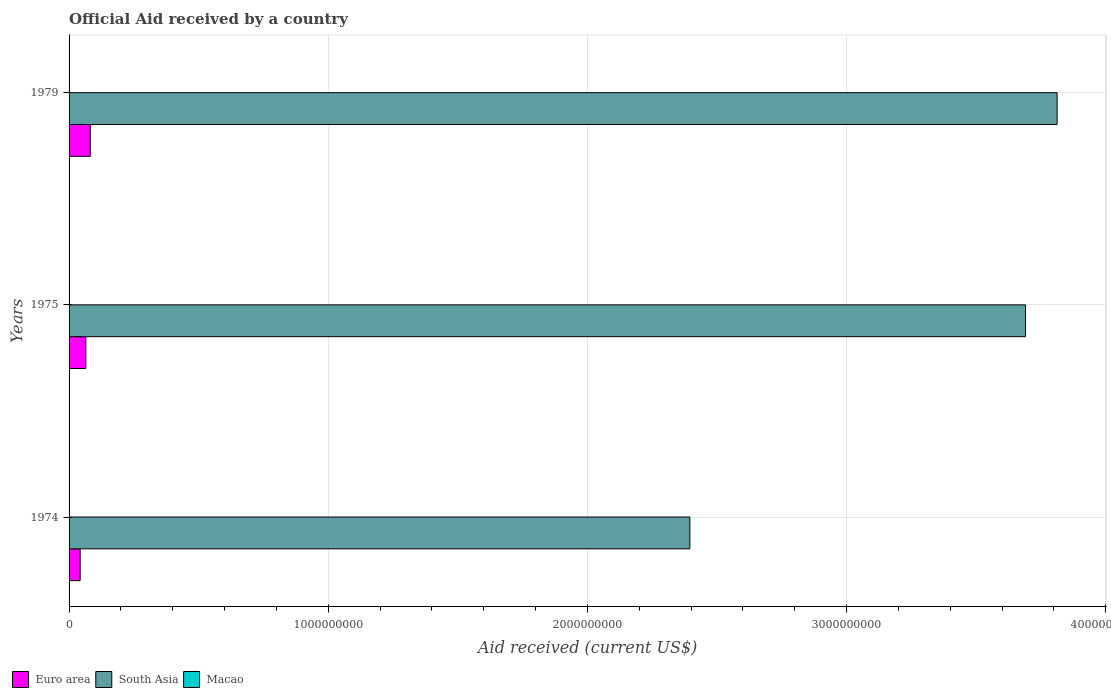How many bars are there on the 1st tick from the top?
Offer a very short reply. 3. What is the label of the 2nd group of bars from the top?
Keep it short and to the point. 1975. What is the net official aid received in Macao in 1975?
Give a very brief answer. 2.00e+04. Across all years, what is the maximum net official aid received in South Asia?
Your answer should be compact. 3.81e+09. Across all years, what is the minimum net official aid received in Euro area?
Make the answer very short. 4.28e+07. In which year was the net official aid received in Macao maximum?
Give a very brief answer. 1974. In which year was the net official aid received in Euro area minimum?
Make the answer very short. 1974. What is the total net official aid received in Euro area in the graph?
Make the answer very short. 1.89e+08. What is the difference between the net official aid received in Euro area in 1975 and that in 1979?
Offer a terse response. -1.69e+07. What is the difference between the net official aid received in South Asia in 1975 and the net official aid received in Euro area in 1974?
Provide a short and direct response. 3.65e+09. What is the average net official aid received in South Asia per year?
Your answer should be very brief. 3.30e+09. In the year 1974, what is the difference between the net official aid received in Macao and net official aid received in South Asia?
Provide a succinct answer. -2.40e+09. What is the ratio of the net official aid received in Euro area in 1975 to that in 1979?
Give a very brief answer. 0.79. Is the net official aid received in South Asia in 1974 less than that in 1979?
Your answer should be very brief. Yes. What is the difference between the highest and the lowest net official aid received in South Asia?
Your answer should be very brief. 1.42e+09. What does the 2nd bar from the top in 1974 represents?
Provide a succinct answer. South Asia. What does the 3rd bar from the bottom in 1979 represents?
Make the answer very short. Macao. Are all the bars in the graph horizontal?
Provide a succinct answer. Yes. What is the difference between two consecutive major ticks on the X-axis?
Keep it short and to the point. 1.00e+09. Does the graph contain any zero values?
Provide a succinct answer. No. Does the graph contain grids?
Give a very brief answer. Yes. Where does the legend appear in the graph?
Make the answer very short. Bottom left. How are the legend labels stacked?
Ensure brevity in your answer.  Horizontal. What is the title of the graph?
Keep it short and to the point. Official Aid received by a country. What is the label or title of the X-axis?
Provide a short and direct response. Aid received (current US$). What is the Aid received (current US$) of Euro area in 1974?
Your response must be concise. 4.28e+07. What is the Aid received (current US$) of South Asia in 1974?
Provide a short and direct response. 2.40e+09. What is the Aid received (current US$) of Macao in 1974?
Offer a very short reply. 3.00e+04. What is the Aid received (current US$) in Euro area in 1975?
Provide a succinct answer. 6.48e+07. What is the Aid received (current US$) of South Asia in 1975?
Your answer should be compact. 3.69e+09. What is the Aid received (current US$) of Euro area in 1979?
Offer a very short reply. 8.17e+07. What is the Aid received (current US$) in South Asia in 1979?
Your response must be concise. 3.81e+09. Across all years, what is the maximum Aid received (current US$) of Euro area?
Keep it short and to the point. 8.17e+07. Across all years, what is the maximum Aid received (current US$) of South Asia?
Your answer should be compact. 3.81e+09. Across all years, what is the minimum Aid received (current US$) in Euro area?
Give a very brief answer. 4.28e+07. Across all years, what is the minimum Aid received (current US$) in South Asia?
Keep it short and to the point. 2.40e+09. Across all years, what is the minimum Aid received (current US$) of Macao?
Make the answer very short. 2.00e+04. What is the total Aid received (current US$) in Euro area in the graph?
Your answer should be compact. 1.89e+08. What is the total Aid received (current US$) in South Asia in the graph?
Offer a very short reply. 9.90e+09. What is the difference between the Aid received (current US$) in Euro area in 1974 and that in 1975?
Keep it short and to the point. -2.20e+07. What is the difference between the Aid received (current US$) of South Asia in 1974 and that in 1975?
Offer a very short reply. -1.29e+09. What is the difference between the Aid received (current US$) of Macao in 1974 and that in 1975?
Provide a succinct answer. 10000. What is the difference between the Aid received (current US$) of Euro area in 1974 and that in 1979?
Your answer should be compact. -3.89e+07. What is the difference between the Aid received (current US$) of South Asia in 1974 and that in 1979?
Your response must be concise. -1.42e+09. What is the difference between the Aid received (current US$) in Euro area in 1975 and that in 1979?
Offer a very short reply. -1.69e+07. What is the difference between the Aid received (current US$) of South Asia in 1975 and that in 1979?
Your answer should be very brief. -1.22e+08. What is the difference between the Aid received (current US$) in Macao in 1975 and that in 1979?
Your answer should be compact. 0. What is the difference between the Aid received (current US$) of Euro area in 1974 and the Aid received (current US$) of South Asia in 1975?
Ensure brevity in your answer.  -3.65e+09. What is the difference between the Aid received (current US$) in Euro area in 1974 and the Aid received (current US$) in Macao in 1975?
Give a very brief answer. 4.28e+07. What is the difference between the Aid received (current US$) in South Asia in 1974 and the Aid received (current US$) in Macao in 1975?
Make the answer very short. 2.40e+09. What is the difference between the Aid received (current US$) of Euro area in 1974 and the Aid received (current US$) of South Asia in 1979?
Keep it short and to the point. -3.77e+09. What is the difference between the Aid received (current US$) of Euro area in 1974 and the Aid received (current US$) of Macao in 1979?
Offer a terse response. 4.28e+07. What is the difference between the Aid received (current US$) of South Asia in 1974 and the Aid received (current US$) of Macao in 1979?
Your answer should be compact. 2.40e+09. What is the difference between the Aid received (current US$) in Euro area in 1975 and the Aid received (current US$) in South Asia in 1979?
Offer a terse response. -3.75e+09. What is the difference between the Aid received (current US$) of Euro area in 1975 and the Aid received (current US$) of Macao in 1979?
Your answer should be very brief. 6.48e+07. What is the difference between the Aid received (current US$) of South Asia in 1975 and the Aid received (current US$) of Macao in 1979?
Offer a terse response. 3.69e+09. What is the average Aid received (current US$) in Euro area per year?
Your answer should be very brief. 6.31e+07. What is the average Aid received (current US$) in South Asia per year?
Keep it short and to the point. 3.30e+09. What is the average Aid received (current US$) in Macao per year?
Your response must be concise. 2.33e+04. In the year 1974, what is the difference between the Aid received (current US$) in Euro area and Aid received (current US$) in South Asia?
Offer a terse response. -2.35e+09. In the year 1974, what is the difference between the Aid received (current US$) in Euro area and Aid received (current US$) in Macao?
Your response must be concise. 4.28e+07. In the year 1974, what is the difference between the Aid received (current US$) in South Asia and Aid received (current US$) in Macao?
Ensure brevity in your answer.  2.40e+09. In the year 1975, what is the difference between the Aid received (current US$) of Euro area and Aid received (current US$) of South Asia?
Provide a short and direct response. -3.63e+09. In the year 1975, what is the difference between the Aid received (current US$) of Euro area and Aid received (current US$) of Macao?
Provide a succinct answer. 6.48e+07. In the year 1975, what is the difference between the Aid received (current US$) in South Asia and Aid received (current US$) in Macao?
Your answer should be very brief. 3.69e+09. In the year 1979, what is the difference between the Aid received (current US$) in Euro area and Aid received (current US$) in South Asia?
Your response must be concise. -3.73e+09. In the year 1979, what is the difference between the Aid received (current US$) in Euro area and Aid received (current US$) in Macao?
Your response must be concise. 8.17e+07. In the year 1979, what is the difference between the Aid received (current US$) in South Asia and Aid received (current US$) in Macao?
Offer a terse response. 3.81e+09. What is the ratio of the Aid received (current US$) in Euro area in 1974 to that in 1975?
Ensure brevity in your answer.  0.66. What is the ratio of the Aid received (current US$) of South Asia in 1974 to that in 1975?
Ensure brevity in your answer.  0.65. What is the ratio of the Aid received (current US$) in Euro area in 1974 to that in 1979?
Provide a succinct answer. 0.52. What is the ratio of the Aid received (current US$) in South Asia in 1974 to that in 1979?
Make the answer very short. 0.63. What is the ratio of the Aid received (current US$) in Euro area in 1975 to that in 1979?
Offer a terse response. 0.79. What is the ratio of the Aid received (current US$) of Macao in 1975 to that in 1979?
Make the answer very short. 1. What is the difference between the highest and the second highest Aid received (current US$) in Euro area?
Make the answer very short. 1.69e+07. What is the difference between the highest and the second highest Aid received (current US$) of South Asia?
Your answer should be very brief. 1.22e+08. What is the difference between the highest and the lowest Aid received (current US$) in Euro area?
Give a very brief answer. 3.89e+07. What is the difference between the highest and the lowest Aid received (current US$) of South Asia?
Provide a short and direct response. 1.42e+09. What is the difference between the highest and the lowest Aid received (current US$) in Macao?
Your response must be concise. 10000. 